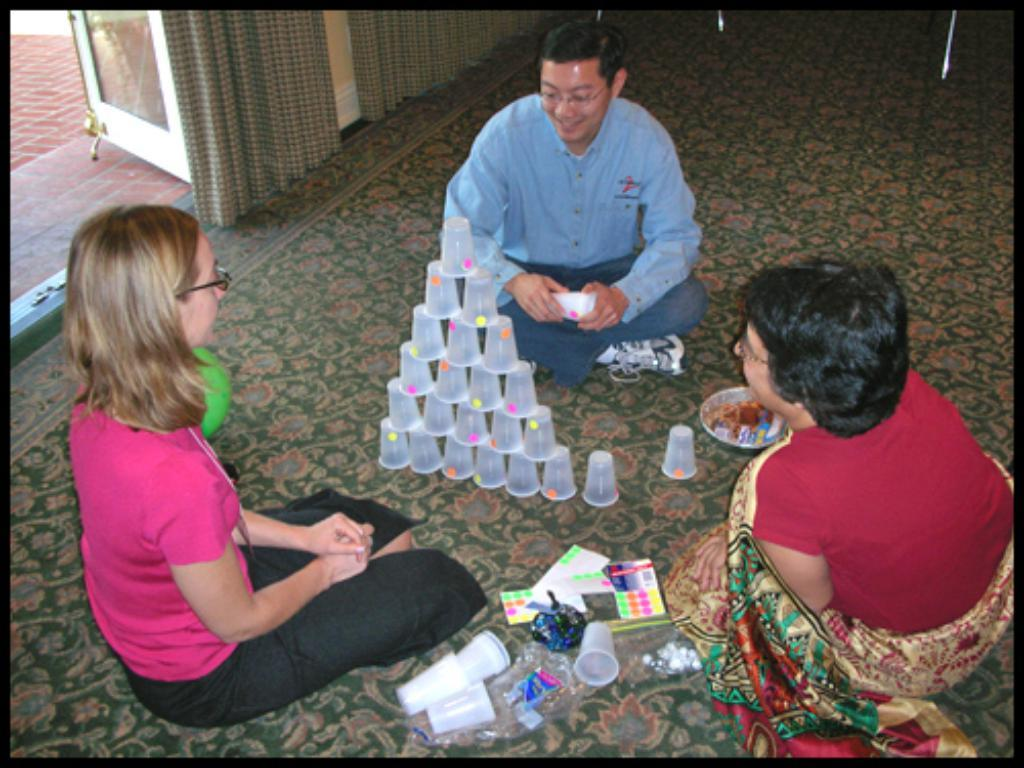What type of window treatment is visible in the image? There are curtains in the image. What architectural feature can be seen in the image? There is a door in the image. How many people are sitting on the floor in the image? There are three people sitting on the floor. What objects can be seen in the image that might be used for drinking? There are glasses in the image. What type of object can be seen in the image that might be used for reading? There is a book in the image. What object can be seen in the image that might be used for eating? There is a plate in the image. What news can be heard coming from the kite in the image? There is no kite present in the image, so no news can be heard from it. What is the cause of the people sitting on the floor in the image? The provided facts do not indicate a specific cause for the people sitting on the floor; they might be sitting for various reasons such as relaxation, conversation, or playing a game. 